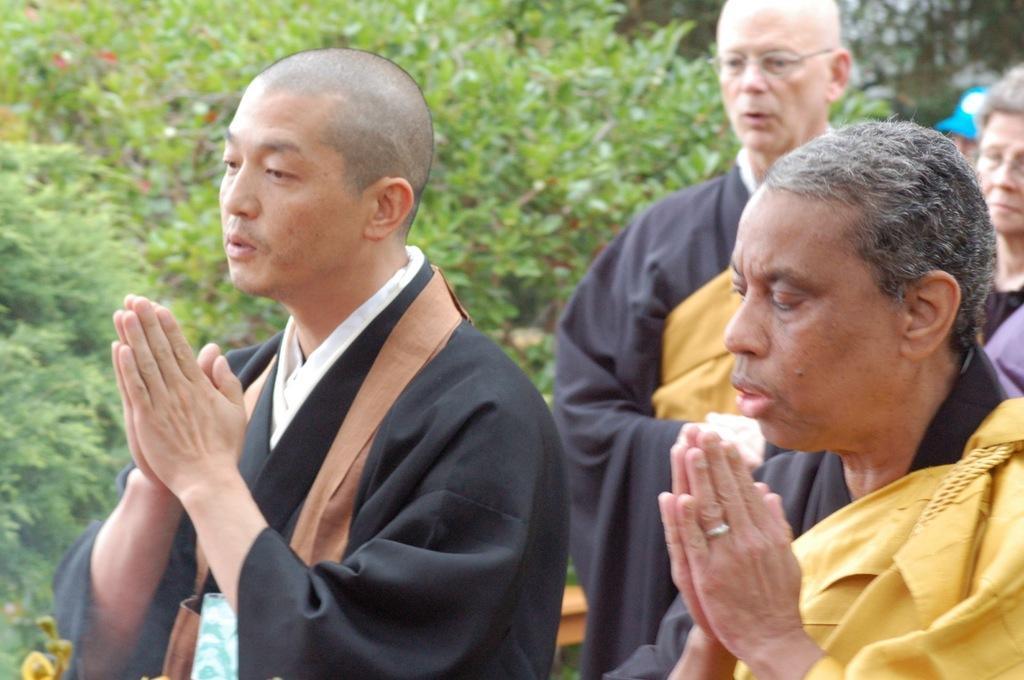How would you summarize this image in a sentence or two? In this image I can see group of people and plants visible. 